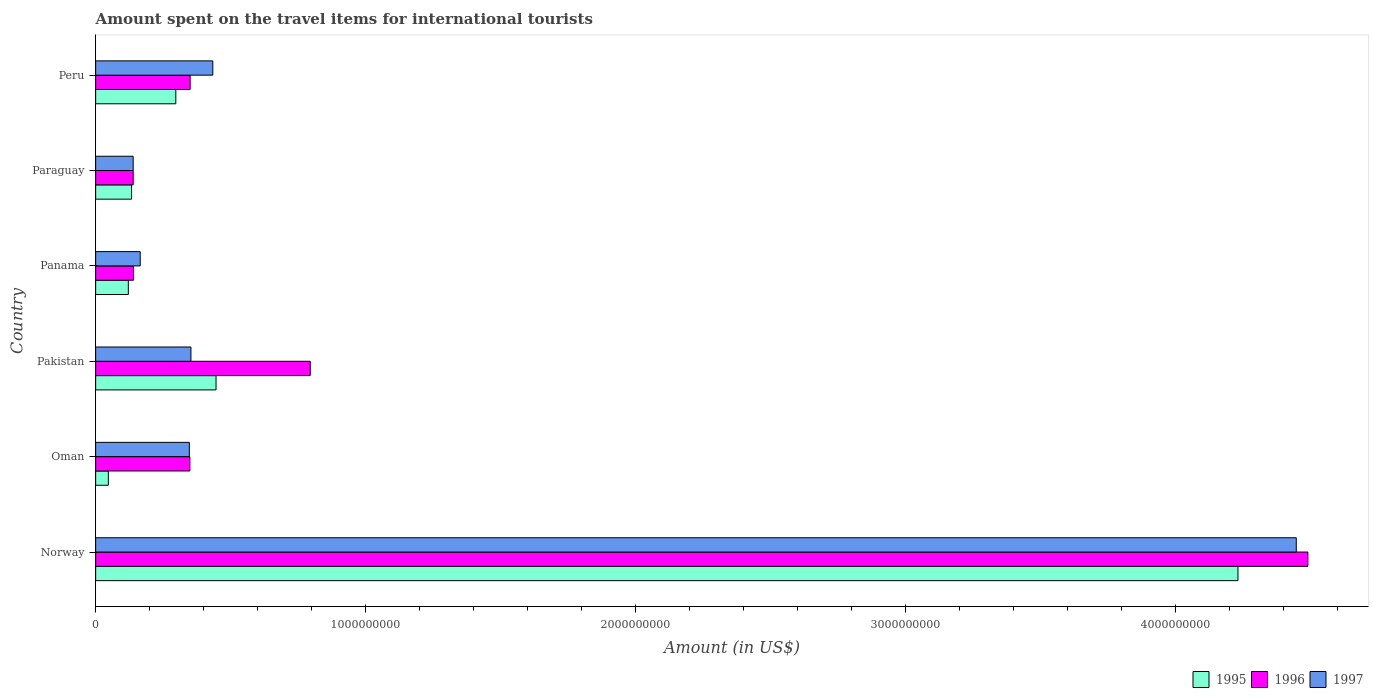How many different coloured bars are there?
Offer a terse response. 3. Are the number of bars per tick equal to the number of legend labels?
Make the answer very short. Yes. How many bars are there on the 6th tick from the top?
Your answer should be compact. 3. What is the label of the 5th group of bars from the top?
Give a very brief answer. Oman. What is the amount spent on the travel items for international tourists in 1996 in Panama?
Provide a short and direct response. 1.40e+08. Across all countries, what is the maximum amount spent on the travel items for international tourists in 1996?
Give a very brief answer. 4.49e+09. Across all countries, what is the minimum amount spent on the travel items for international tourists in 1997?
Provide a succinct answer. 1.39e+08. In which country was the amount spent on the travel items for international tourists in 1996 maximum?
Your response must be concise. Norway. In which country was the amount spent on the travel items for international tourists in 1995 minimum?
Your response must be concise. Oman. What is the total amount spent on the travel items for international tourists in 1997 in the graph?
Provide a succinct answer. 5.89e+09. What is the difference between the amount spent on the travel items for international tourists in 1997 in Panama and that in Paraguay?
Keep it short and to the point. 2.60e+07. What is the difference between the amount spent on the travel items for international tourists in 1995 in Peru and the amount spent on the travel items for international tourists in 1996 in Pakistan?
Your response must be concise. -4.98e+08. What is the average amount spent on the travel items for international tourists in 1996 per country?
Provide a short and direct response. 1.04e+09. What is the difference between the amount spent on the travel items for international tourists in 1995 and amount spent on the travel items for international tourists in 1997 in Oman?
Your answer should be very brief. -3.00e+08. In how many countries, is the amount spent on the travel items for international tourists in 1995 greater than 3200000000 US$?
Your response must be concise. 1. What is the ratio of the amount spent on the travel items for international tourists in 1996 in Panama to that in Paraguay?
Ensure brevity in your answer.  1.01. Is the amount spent on the travel items for international tourists in 1997 in Oman less than that in Peru?
Provide a succinct answer. Yes. Is the difference between the amount spent on the travel items for international tourists in 1995 in Oman and Paraguay greater than the difference between the amount spent on the travel items for international tourists in 1997 in Oman and Paraguay?
Your response must be concise. No. What is the difference between the highest and the second highest amount spent on the travel items for international tourists in 1996?
Give a very brief answer. 3.70e+09. What is the difference between the highest and the lowest amount spent on the travel items for international tourists in 1995?
Offer a very short reply. 4.18e+09. What does the 3rd bar from the bottom in Pakistan represents?
Keep it short and to the point. 1997. Is it the case that in every country, the sum of the amount spent on the travel items for international tourists in 1996 and amount spent on the travel items for international tourists in 1995 is greater than the amount spent on the travel items for international tourists in 1997?
Offer a very short reply. Yes. How many bars are there?
Make the answer very short. 18. Are all the bars in the graph horizontal?
Give a very brief answer. Yes. What is the difference between two consecutive major ticks on the X-axis?
Your answer should be very brief. 1.00e+09. Does the graph contain grids?
Your answer should be very brief. No. What is the title of the graph?
Offer a terse response. Amount spent on the travel items for international tourists. What is the label or title of the Y-axis?
Provide a succinct answer. Country. What is the Amount (in US$) of 1995 in Norway?
Your response must be concise. 4.23e+09. What is the Amount (in US$) in 1996 in Norway?
Make the answer very short. 4.49e+09. What is the Amount (in US$) in 1997 in Norway?
Your response must be concise. 4.45e+09. What is the Amount (in US$) in 1995 in Oman?
Provide a succinct answer. 4.70e+07. What is the Amount (in US$) of 1996 in Oman?
Provide a succinct answer. 3.49e+08. What is the Amount (in US$) of 1997 in Oman?
Make the answer very short. 3.47e+08. What is the Amount (in US$) in 1995 in Pakistan?
Offer a terse response. 4.46e+08. What is the Amount (in US$) of 1996 in Pakistan?
Your answer should be compact. 7.95e+08. What is the Amount (in US$) in 1997 in Pakistan?
Ensure brevity in your answer.  3.53e+08. What is the Amount (in US$) in 1995 in Panama?
Your answer should be compact. 1.21e+08. What is the Amount (in US$) of 1996 in Panama?
Your answer should be compact. 1.40e+08. What is the Amount (in US$) in 1997 in Panama?
Provide a succinct answer. 1.65e+08. What is the Amount (in US$) in 1995 in Paraguay?
Keep it short and to the point. 1.33e+08. What is the Amount (in US$) in 1996 in Paraguay?
Make the answer very short. 1.39e+08. What is the Amount (in US$) in 1997 in Paraguay?
Make the answer very short. 1.39e+08. What is the Amount (in US$) of 1995 in Peru?
Provide a short and direct response. 2.97e+08. What is the Amount (in US$) of 1996 in Peru?
Give a very brief answer. 3.50e+08. What is the Amount (in US$) of 1997 in Peru?
Give a very brief answer. 4.34e+08. Across all countries, what is the maximum Amount (in US$) in 1995?
Your answer should be compact. 4.23e+09. Across all countries, what is the maximum Amount (in US$) in 1996?
Provide a succinct answer. 4.49e+09. Across all countries, what is the maximum Amount (in US$) in 1997?
Provide a short and direct response. 4.45e+09. Across all countries, what is the minimum Amount (in US$) of 1995?
Provide a succinct answer. 4.70e+07. Across all countries, what is the minimum Amount (in US$) in 1996?
Ensure brevity in your answer.  1.39e+08. Across all countries, what is the minimum Amount (in US$) of 1997?
Make the answer very short. 1.39e+08. What is the total Amount (in US$) in 1995 in the graph?
Your answer should be very brief. 5.28e+09. What is the total Amount (in US$) of 1996 in the graph?
Your answer should be very brief. 6.26e+09. What is the total Amount (in US$) of 1997 in the graph?
Give a very brief answer. 5.89e+09. What is the difference between the Amount (in US$) of 1995 in Norway and that in Oman?
Provide a succinct answer. 4.18e+09. What is the difference between the Amount (in US$) of 1996 in Norway and that in Oman?
Your answer should be very brief. 4.14e+09. What is the difference between the Amount (in US$) of 1997 in Norway and that in Oman?
Keep it short and to the point. 4.10e+09. What is the difference between the Amount (in US$) in 1995 in Norway and that in Pakistan?
Give a very brief answer. 3.79e+09. What is the difference between the Amount (in US$) in 1996 in Norway and that in Pakistan?
Provide a succinct answer. 3.70e+09. What is the difference between the Amount (in US$) of 1997 in Norway and that in Pakistan?
Keep it short and to the point. 4.10e+09. What is the difference between the Amount (in US$) in 1995 in Norway and that in Panama?
Your answer should be very brief. 4.11e+09. What is the difference between the Amount (in US$) of 1996 in Norway and that in Panama?
Your response must be concise. 4.35e+09. What is the difference between the Amount (in US$) of 1997 in Norway and that in Panama?
Provide a succinct answer. 4.28e+09. What is the difference between the Amount (in US$) in 1995 in Norway and that in Paraguay?
Your answer should be very brief. 4.10e+09. What is the difference between the Amount (in US$) of 1996 in Norway and that in Paraguay?
Make the answer very short. 4.35e+09. What is the difference between the Amount (in US$) in 1997 in Norway and that in Paraguay?
Offer a terse response. 4.31e+09. What is the difference between the Amount (in US$) of 1995 in Norway and that in Peru?
Provide a succinct answer. 3.94e+09. What is the difference between the Amount (in US$) of 1996 in Norway and that in Peru?
Keep it short and to the point. 4.14e+09. What is the difference between the Amount (in US$) of 1997 in Norway and that in Peru?
Provide a succinct answer. 4.01e+09. What is the difference between the Amount (in US$) in 1995 in Oman and that in Pakistan?
Offer a very short reply. -3.99e+08. What is the difference between the Amount (in US$) of 1996 in Oman and that in Pakistan?
Ensure brevity in your answer.  -4.46e+08. What is the difference between the Amount (in US$) in 1997 in Oman and that in Pakistan?
Offer a terse response. -6.00e+06. What is the difference between the Amount (in US$) in 1995 in Oman and that in Panama?
Keep it short and to the point. -7.40e+07. What is the difference between the Amount (in US$) in 1996 in Oman and that in Panama?
Your response must be concise. 2.09e+08. What is the difference between the Amount (in US$) in 1997 in Oman and that in Panama?
Offer a very short reply. 1.82e+08. What is the difference between the Amount (in US$) in 1995 in Oman and that in Paraguay?
Your answer should be compact. -8.60e+07. What is the difference between the Amount (in US$) in 1996 in Oman and that in Paraguay?
Offer a very short reply. 2.10e+08. What is the difference between the Amount (in US$) in 1997 in Oman and that in Paraguay?
Offer a very short reply. 2.08e+08. What is the difference between the Amount (in US$) in 1995 in Oman and that in Peru?
Ensure brevity in your answer.  -2.50e+08. What is the difference between the Amount (in US$) of 1996 in Oman and that in Peru?
Keep it short and to the point. -1.00e+06. What is the difference between the Amount (in US$) of 1997 in Oman and that in Peru?
Provide a short and direct response. -8.70e+07. What is the difference between the Amount (in US$) in 1995 in Pakistan and that in Panama?
Your response must be concise. 3.25e+08. What is the difference between the Amount (in US$) of 1996 in Pakistan and that in Panama?
Give a very brief answer. 6.55e+08. What is the difference between the Amount (in US$) of 1997 in Pakistan and that in Panama?
Your answer should be very brief. 1.88e+08. What is the difference between the Amount (in US$) in 1995 in Pakistan and that in Paraguay?
Provide a succinct answer. 3.13e+08. What is the difference between the Amount (in US$) in 1996 in Pakistan and that in Paraguay?
Your response must be concise. 6.56e+08. What is the difference between the Amount (in US$) in 1997 in Pakistan and that in Paraguay?
Your answer should be compact. 2.14e+08. What is the difference between the Amount (in US$) in 1995 in Pakistan and that in Peru?
Give a very brief answer. 1.49e+08. What is the difference between the Amount (in US$) of 1996 in Pakistan and that in Peru?
Offer a terse response. 4.45e+08. What is the difference between the Amount (in US$) of 1997 in Pakistan and that in Peru?
Keep it short and to the point. -8.10e+07. What is the difference between the Amount (in US$) of 1995 in Panama and that in Paraguay?
Make the answer very short. -1.20e+07. What is the difference between the Amount (in US$) in 1996 in Panama and that in Paraguay?
Offer a terse response. 1.00e+06. What is the difference between the Amount (in US$) of 1997 in Panama and that in Paraguay?
Your answer should be compact. 2.60e+07. What is the difference between the Amount (in US$) of 1995 in Panama and that in Peru?
Your answer should be compact. -1.76e+08. What is the difference between the Amount (in US$) in 1996 in Panama and that in Peru?
Offer a terse response. -2.10e+08. What is the difference between the Amount (in US$) of 1997 in Panama and that in Peru?
Keep it short and to the point. -2.69e+08. What is the difference between the Amount (in US$) in 1995 in Paraguay and that in Peru?
Offer a terse response. -1.64e+08. What is the difference between the Amount (in US$) in 1996 in Paraguay and that in Peru?
Your answer should be compact. -2.11e+08. What is the difference between the Amount (in US$) in 1997 in Paraguay and that in Peru?
Your answer should be very brief. -2.95e+08. What is the difference between the Amount (in US$) of 1995 in Norway and the Amount (in US$) of 1996 in Oman?
Provide a succinct answer. 3.88e+09. What is the difference between the Amount (in US$) of 1995 in Norway and the Amount (in US$) of 1997 in Oman?
Your answer should be compact. 3.88e+09. What is the difference between the Amount (in US$) in 1996 in Norway and the Amount (in US$) in 1997 in Oman?
Provide a succinct answer. 4.14e+09. What is the difference between the Amount (in US$) in 1995 in Norway and the Amount (in US$) in 1996 in Pakistan?
Make the answer very short. 3.44e+09. What is the difference between the Amount (in US$) of 1995 in Norway and the Amount (in US$) of 1997 in Pakistan?
Keep it short and to the point. 3.88e+09. What is the difference between the Amount (in US$) of 1996 in Norway and the Amount (in US$) of 1997 in Pakistan?
Offer a terse response. 4.14e+09. What is the difference between the Amount (in US$) in 1995 in Norway and the Amount (in US$) in 1996 in Panama?
Your response must be concise. 4.09e+09. What is the difference between the Amount (in US$) of 1995 in Norway and the Amount (in US$) of 1997 in Panama?
Your response must be concise. 4.07e+09. What is the difference between the Amount (in US$) of 1996 in Norway and the Amount (in US$) of 1997 in Panama?
Your answer should be compact. 4.33e+09. What is the difference between the Amount (in US$) in 1995 in Norway and the Amount (in US$) in 1996 in Paraguay?
Ensure brevity in your answer.  4.09e+09. What is the difference between the Amount (in US$) of 1995 in Norway and the Amount (in US$) of 1997 in Paraguay?
Keep it short and to the point. 4.09e+09. What is the difference between the Amount (in US$) of 1996 in Norway and the Amount (in US$) of 1997 in Paraguay?
Ensure brevity in your answer.  4.35e+09. What is the difference between the Amount (in US$) of 1995 in Norway and the Amount (in US$) of 1996 in Peru?
Your answer should be compact. 3.88e+09. What is the difference between the Amount (in US$) in 1995 in Norway and the Amount (in US$) in 1997 in Peru?
Your answer should be compact. 3.80e+09. What is the difference between the Amount (in US$) of 1996 in Norway and the Amount (in US$) of 1997 in Peru?
Make the answer very short. 4.06e+09. What is the difference between the Amount (in US$) of 1995 in Oman and the Amount (in US$) of 1996 in Pakistan?
Offer a terse response. -7.48e+08. What is the difference between the Amount (in US$) in 1995 in Oman and the Amount (in US$) in 1997 in Pakistan?
Your response must be concise. -3.06e+08. What is the difference between the Amount (in US$) in 1995 in Oman and the Amount (in US$) in 1996 in Panama?
Your answer should be very brief. -9.30e+07. What is the difference between the Amount (in US$) of 1995 in Oman and the Amount (in US$) of 1997 in Panama?
Provide a succinct answer. -1.18e+08. What is the difference between the Amount (in US$) in 1996 in Oman and the Amount (in US$) in 1997 in Panama?
Your answer should be very brief. 1.84e+08. What is the difference between the Amount (in US$) in 1995 in Oman and the Amount (in US$) in 1996 in Paraguay?
Keep it short and to the point. -9.20e+07. What is the difference between the Amount (in US$) in 1995 in Oman and the Amount (in US$) in 1997 in Paraguay?
Make the answer very short. -9.20e+07. What is the difference between the Amount (in US$) of 1996 in Oman and the Amount (in US$) of 1997 in Paraguay?
Offer a terse response. 2.10e+08. What is the difference between the Amount (in US$) in 1995 in Oman and the Amount (in US$) in 1996 in Peru?
Your response must be concise. -3.03e+08. What is the difference between the Amount (in US$) of 1995 in Oman and the Amount (in US$) of 1997 in Peru?
Your answer should be very brief. -3.87e+08. What is the difference between the Amount (in US$) in 1996 in Oman and the Amount (in US$) in 1997 in Peru?
Offer a very short reply. -8.50e+07. What is the difference between the Amount (in US$) in 1995 in Pakistan and the Amount (in US$) in 1996 in Panama?
Provide a succinct answer. 3.06e+08. What is the difference between the Amount (in US$) in 1995 in Pakistan and the Amount (in US$) in 1997 in Panama?
Give a very brief answer. 2.81e+08. What is the difference between the Amount (in US$) of 1996 in Pakistan and the Amount (in US$) of 1997 in Panama?
Your response must be concise. 6.30e+08. What is the difference between the Amount (in US$) of 1995 in Pakistan and the Amount (in US$) of 1996 in Paraguay?
Make the answer very short. 3.07e+08. What is the difference between the Amount (in US$) in 1995 in Pakistan and the Amount (in US$) in 1997 in Paraguay?
Offer a terse response. 3.07e+08. What is the difference between the Amount (in US$) in 1996 in Pakistan and the Amount (in US$) in 1997 in Paraguay?
Your answer should be compact. 6.56e+08. What is the difference between the Amount (in US$) in 1995 in Pakistan and the Amount (in US$) in 1996 in Peru?
Ensure brevity in your answer.  9.60e+07. What is the difference between the Amount (in US$) in 1996 in Pakistan and the Amount (in US$) in 1997 in Peru?
Provide a succinct answer. 3.61e+08. What is the difference between the Amount (in US$) of 1995 in Panama and the Amount (in US$) of 1996 in Paraguay?
Provide a short and direct response. -1.80e+07. What is the difference between the Amount (in US$) in 1995 in Panama and the Amount (in US$) in 1997 in Paraguay?
Provide a short and direct response. -1.80e+07. What is the difference between the Amount (in US$) of 1996 in Panama and the Amount (in US$) of 1997 in Paraguay?
Ensure brevity in your answer.  1.00e+06. What is the difference between the Amount (in US$) in 1995 in Panama and the Amount (in US$) in 1996 in Peru?
Provide a succinct answer. -2.29e+08. What is the difference between the Amount (in US$) in 1995 in Panama and the Amount (in US$) in 1997 in Peru?
Your answer should be very brief. -3.13e+08. What is the difference between the Amount (in US$) in 1996 in Panama and the Amount (in US$) in 1997 in Peru?
Ensure brevity in your answer.  -2.94e+08. What is the difference between the Amount (in US$) of 1995 in Paraguay and the Amount (in US$) of 1996 in Peru?
Provide a short and direct response. -2.17e+08. What is the difference between the Amount (in US$) of 1995 in Paraguay and the Amount (in US$) of 1997 in Peru?
Give a very brief answer. -3.01e+08. What is the difference between the Amount (in US$) of 1996 in Paraguay and the Amount (in US$) of 1997 in Peru?
Make the answer very short. -2.95e+08. What is the average Amount (in US$) in 1995 per country?
Ensure brevity in your answer.  8.79e+08. What is the average Amount (in US$) in 1996 per country?
Provide a short and direct response. 1.04e+09. What is the average Amount (in US$) in 1997 per country?
Keep it short and to the point. 9.81e+08. What is the difference between the Amount (in US$) in 1995 and Amount (in US$) in 1996 in Norway?
Provide a succinct answer. -2.59e+08. What is the difference between the Amount (in US$) in 1995 and Amount (in US$) in 1997 in Norway?
Your response must be concise. -2.16e+08. What is the difference between the Amount (in US$) of 1996 and Amount (in US$) of 1997 in Norway?
Your response must be concise. 4.30e+07. What is the difference between the Amount (in US$) of 1995 and Amount (in US$) of 1996 in Oman?
Ensure brevity in your answer.  -3.02e+08. What is the difference between the Amount (in US$) of 1995 and Amount (in US$) of 1997 in Oman?
Ensure brevity in your answer.  -3.00e+08. What is the difference between the Amount (in US$) of 1996 and Amount (in US$) of 1997 in Oman?
Your answer should be very brief. 2.00e+06. What is the difference between the Amount (in US$) of 1995 and Amount (in US$) of 1996 in Pakistan?
Keep it short and to the point. -3.49e+08. What is the difference between the Amount (in US$) in 1995 and Amount (in US$) in 1997 in Pakistan?
Make the answer very short. 9.30e+07. What is the difference between the Amount (in US$) of 1996 and Amount (in US$) of 1997 in Pakistan?
Offer a very short reply. 4.42e+08. What is the difference between the Amount (in US$) in 1995 and Amount (in US$) in 1996 in Panama?
Your answer should be very brief. -1.90e+07. What is the difference between the Amount (in US$) in 1995 and Amount (in US$) in 1997 in Panama?
Provide a succinct answer. -4.40e+07. What is the difference between the Amount (in US$) in 1996 and Amount (in US$) in 1997 in Panama?
Give a very brief answer. -2.50e+07. What is the difference between the Amount (in US$) of 1995 and Amount (in US$) of 1996 in Paraguay?
Ensure brevity in your answer.  -6.00e+06. What is the difference between the Amount (in US$) in 1995 and Amount (in US$) in 1997 in Paraguay?
Your response must be concise. -6.00e+06. What is the difference between the Amount (in US$) of 1996 and Amount (in US$) of 1997 in Paraguay?
Your response must be concise. 0. What is the difference between the Amount (in US$) of 1995 and Amount (in US$) of 1996 in Peru?
Keep it short and to the point. -5.30e+07. What is the difference between the Amount (in US$) of 1995 and Amount (in US$) of 1997 in Peru?
Your answer should be very brief. -1.37e+08. What is the difference between the Amount (in US$) in 1996 and Amount (in US$) in 1997 in Peru?
Give a very brief answer. -8.40e+07. What is the ratio of the Amount (in US$) in 1995 in Norway to that in Oman?
Give a very brief answer. 90.04. What is the ratio of the Amount (in US$) in 1996 in Norway to that in Oman?
Offer a very short reply. 12.87. What is the ratio of the Amount (in US$) in 1997 in Norway to that in Oman?
Make the answer very short. 12.82. What is the ratio of the Amount (in US$) of 1995 in Norway to that in Pakistan?
Provide a short and direct response. 9.49. What is the ratio of the Amount (in US$) of 1996 in Norway to that in Pakistan?
Provide a short and direct response. 5.65. What is the ratio of the Amount (in US$) of 1997 in Norway to that in Pakistan?
Offer a terse response. 12.6. What is the ratio of the Amount (in US$) of 1995 in Norway to that in Panama?
Offer a very short reply. 34.98. What is the ratio of the Amount (in US$) of 1996 in Norway to that in Panama?
Make the answer very short. 32.08. What is the ratio of the Amount (in US$) in 1997 in Norway to that in Panama?
Offer a terse response. 26.96. What is the ratio of the Amount (in US$) in 1995 in Norway to that in Paraguay?
Offer a very short reply. 31.82. What is the ratio of the Amount (in US$) of 1996 in Norway to that in Paraguay?
Provide a succinct answer. 32.31. What is the ratio of the Amount (in US$) in 1995 in Norway to that in Peru?
Provide a short and direct response. 14.25. What is the ratio of the Amount (in US$) of 1996 in Norway to that in Peru?
Ensure brevity in your answer.  12.83. What is the ratio of the Amount (in US$) in 1997 in Norway to that in Peru?
Make the answer very short. 10.25. What is the ratio of the Amount (in US$) of 1995 in Oman to that in Pakistan?
Provide a succinct answer. 0.11. What is the ratio of the Amount (in US$) of 1996 in Oman to that in Pakistan?
Your answer should be very brief. 0.44. What is the ratio of the Amount (in US$) in 1997 in Oman to that in Pakistan?
Offer a terse response. 0.98. What is the ratio of the Amount (in US$) in 1995 in Oman to that in Panama?
Offer a terse response. 0.39. What is the ratio of the Amount (in US$) of 1996 in Oman to that in Panama?
Give a very brief answer. 2.49. What is the ratio of the Amount (in US$) of 1997 in Oman to that in Panama?
Ensure brevity in your answer.  2.1. What is the ratio of the Amount (in US$) in 1995 in Oman to that in Paraguay?
Give a very brief answer. 0.35. What is the ratio of the Amount (in US$) in 1996 in Oman to that in Paraguay?
Your answer should be compact. 2.51. What is the ratio of the Amount (in US$) of 1997 in Oman to that in Paraguay?
Give a very brief answer. 2.5. What is the ratio of the Amount (in US$) of 1995 in Oman to that in Peru?
Offer a terse response. 0.16. What is the ratio of the Amount (in US$) of 1997 in Oman to that in Peru?
Offer a very short reply. 0.8. What is the ratio of the Amount (in US$) of 1995 in Pakistan to that in Panama?
Provide a short and direct response. 3.69. What is the ratio of the Amount (in US$) of 1996 in Pakistan to that in Panama?
Provide a short and direct response. 5.68. What is the ratio of the Amount (in US$) of 1997 in Pakistan to that in Panama?
Make the answer very short. 2.14. What is the ratio of the Amount (in US$) in 1995 in Pakistan to that in Paraguay?
Keep it short and to the point. 3.35. What is the ratio of the Amount (in US$) in 1996 in Pakistan to that in Paraguay?
Your answer should be compact. 5.72. What is the ratio of the Amount (in US$) of 1997 in Pakistan to that in Paraguay?
Offer a very short reply. 2.54. What is the ratio of the Amount (in US$) of 1995 in Pakistan to that in Peru?
Make the answer very short. 1.5. What is the ratio of the Amount (in US$) of 1996 in Pakistan to that in Peru?
Your response must be concise. 2.27. What is the ratio of the Amount (in US$) of 1997 in Pakistan to that in Peru?
Your answer should be very brief. 0.81. What is the ratio of the Amount (in US$) in 1995 in Panama to that in Paraguay?
Your answer should be compact. 0.91. What is the ratio of the Amount (in US$) in 1997 in Panama to that in Paraguay?
Keep it short and to the point. 1.19. What is the ratio of the Amount (in US$) in 1995 in Panama to that in Peru?
Offer a very short reply. 0.41. What is the ratio of the Amount (in US$) of 1997 in Panama to that in Peru?
Give a very brief answer. 0.38. What is the ratio of the Amount (in US$) of 1995 in Paraguay to that in Peru?
Your answer should be compact. 0.45. What is the ratio of the Amount (in US$) of 1996 in Paraguay to that in Peru?
Make the answer very short. 0.4. What is the ratio of the Amount (in US$) in 1997 in Paraguay to that in Peru?
Provide a short and direct response. 0.32. What is the difference between the highest and the second highest Amount (in US$) of 1995?
Your answer should be very brief. 3.79e+09. What is the difference between the highest and the second highest Amount (in US$) in 1996?
Give a very brief answer. 3.70e+09. What is the difference between the highest and the second highest Amount (in US$) in 1997?
Offer a very short reply. 4.01e+09. What is the difference between the highest and the lowest Amount (in US$) in 1995?
Make the answer very short. 4.18e+09. What is the difference between the highest and the lowest Amount (in US$) of 1996?
Give a very brief answer. 4.35e+09. What is the difference between the highest and the lowest Amount (in US$) in 1997?
Make the answer very short. 4.31e+09. 